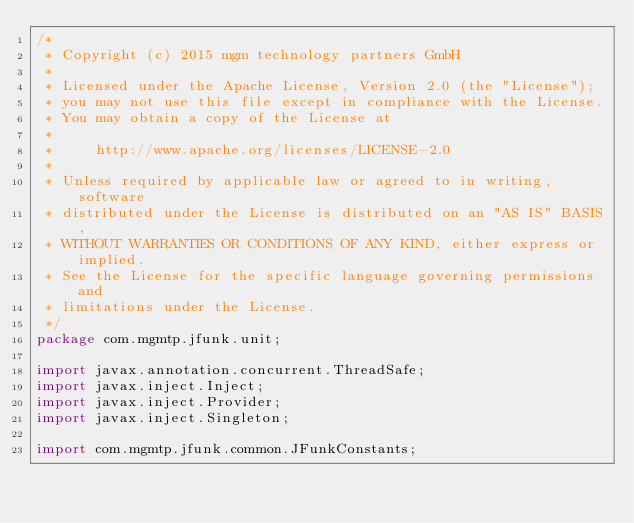Convert code to text. <code><loc_0><loc_0><loc_500><loc_500><_Java_>/*
 * Copyright (c) 2015 mgm technology partners GmbH
 *
 * Licensed under the Apache License, Version 2.0 (the "License");
 * you may not use this file except in compliance with the License.
 * You may obtain a copy of the License at
 *
 *     http://www.apache.org/licenses/LICENSE-2.0
 *
 * Unless required by applicable law or agreed to in writing, software
 * distributed under the License is distributed on an "AS IS" BASIS,
 * WITHOUT WARRANTIES OR CONDITIONS OF ANY KIND, either express or implied.
 * See the License for the specific language governing permissions and
 * limitations under the License.
 */
package com.mgmtp.jfunk.unit;

import javax.annotation.concurrent.ThreadSafe;
import javax.inject.Inject;
import javax.inject.Provider;
import javax.inject.Singleton;

import com.mgmtp.jfunk.common.JFunkConstants;</code> 